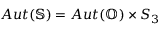<formula> <loc_0><loc_0><loc_500><loc_500>A u t ( \mathbb { S } ) = A u t ( \mathbb { O } ) \times S _ { 3 }</formula> 